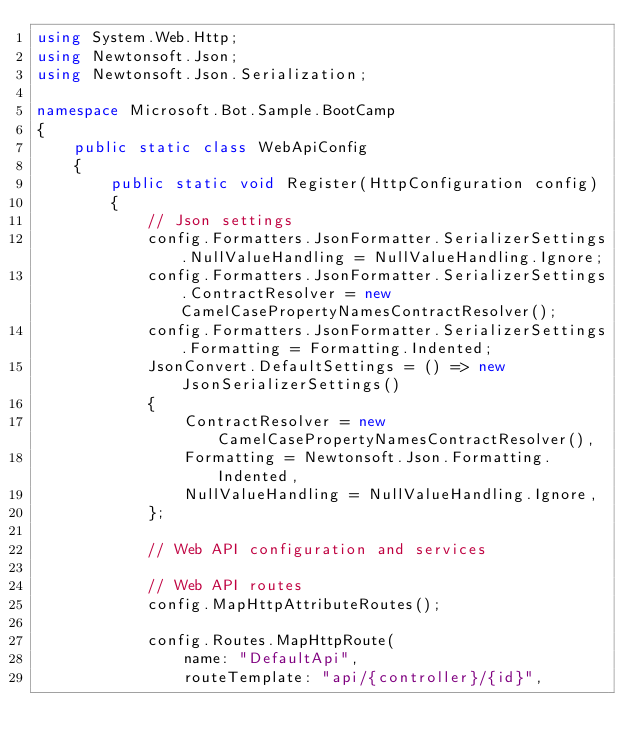Convert code to text. <code><loc_0><loc_0><loc_500><loc_500><_C#_>using System.Web.Http;
using Newtonsoft.Json;
using Newtonsoft.Json.Serialization;

namespace Microsoft.Bot.Sample.BootCamp
{
    public static class WebApiConfig
    {
        public static void Register(HttpConfiguration config)
        {
            // Json settings
            config.Formatters.JsonFormatter.SerializerSettings.NullValueHandling = NullValueHandling.Ignore;
            config.Formatters.JsonFormatter.SerializerSettings.ContractResolver = new CamelCasePropertyNamesContractResolver();
            config.Formatters.JsonFormatter.SerializerSettings.Formatting = Formatting.Indented;
            JsonConvert.DefaultSettings = () => new JsonSerializerSettings()
            {
                ContractResolver = new CamelCasePropertyNamesContractResolver(),
                Formatting = Newtonsoft.Json.Formatting.Indented,
                NullValueHandling = NullValueHandling.Ignore,
            };

            // Web API configuration and services

            // Web API routes
            config.MapHttpAttributeRoutes();

            config.Routes.MapHttpRoute(
                name: "DefaultApi",
                routeTemplate: "api/{controller}/{id}",</code> 